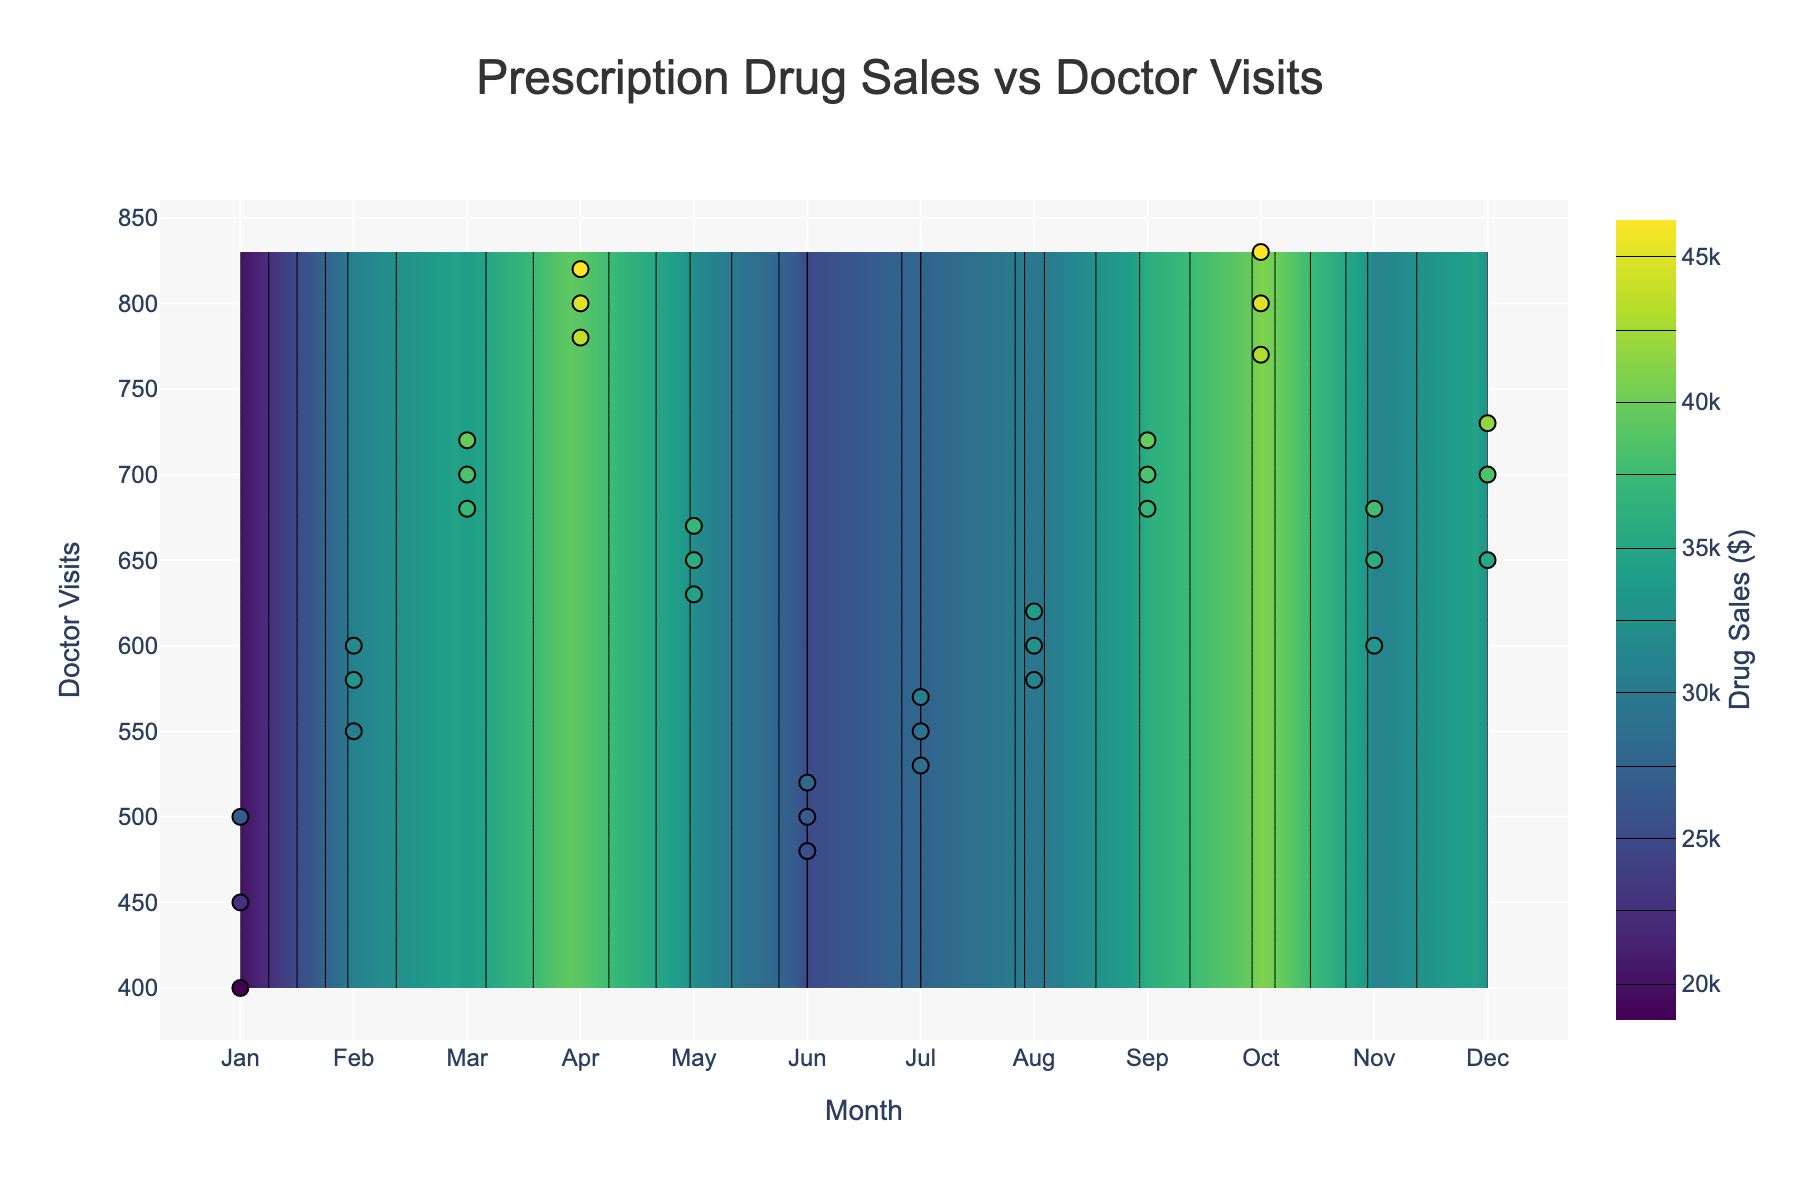What's the title of the plot? The title of the plot is displayed at the top and typically encapsulates the main focus of the figure. It helps viewers quickly understand the subject of the visual.
Answer: Prescription Drug Sales vs Doctor Visits Which month has the highest doctor visits? By examining the x-axis labeled 'Month' and corresponding y-values for each month, one can find the month with the highest y-value.
Answer: October During which months do drug sales reach $35,000? Drug sales are represented by the color gradient. By looking at the contour lines and the colorbar which indicates the value ranges, we find that drug sales reach $35,000 in March, September, and December.
Answer: March, September, December Does an increase in doctor visits generally correspond to an increase in prescription drug sales? Observing the scatter plot along with the contour lines, one can see that higher doctor visit frequencies generally align with higher prescription drug sales, indicating a positive correlation.
Answer: Yes Compare the prescription drug sales between January and July. Which month has higher sales on average? By pinpointing the data points corresponding to January and July and noting their dollar values, we can average the values for each month. In January, the sales are $23,000, $26,000, and $20,000, averaging $23,000. In July, the sales are $28,000, $29,000, and $27,500, averaging $28,500.
Answer: July What is the overall trend of doctor visits against time from January to December? By following the x-axis from January to December and observing the scattering pattern and contour lines, we can determine the trend. Initially, doctor visits increase, slightly drop in May and June, then steadily increase again towards October, and slightly reduce in the final months.
Answer: Increasing with fluctuation What's the range of doctor visits for the month of August? By locating the points that correspond to August on the x-axis and noting the y-values for doctor visits, one can identify the range of visits. For August, the visits are 600, 620, and 580.
Answer: 580-620 In which month do we see the steepest increase in drug sales relative to doctor visits? By watching the contour gradients and the sharp changes in the z values across adjacent months, and aligning them with y increases in doctor visits, it can be seen that February has the steeper increase in drug sales relative to January.
Answer: February Which month's data points are the most dispersed in terms of doctor visits? By comparing the spread of data points along the y-axis for each month, it is evident that November shows a wider dispersion of doctor visit values (600, 650, 680).
Answer: November 